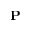Convert formula to latex. <formula><loc_0><loc_0><loc_500><loc_500>P</formula> 